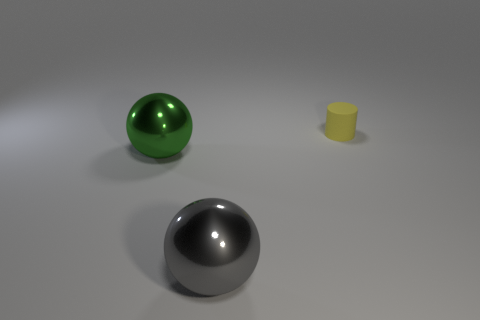How many objects are in the image, and can you describe their shapes and materials? There are three objects in the image: a large green metallic sphere, a smaller grey metallic sphere, and a yellow cylindrical object with a matte surface. Do the objects appear to be affected by a light source? Yes, the objects cast soft shadows on the ground, suggesting the presence of a diffuse overhead light source. 